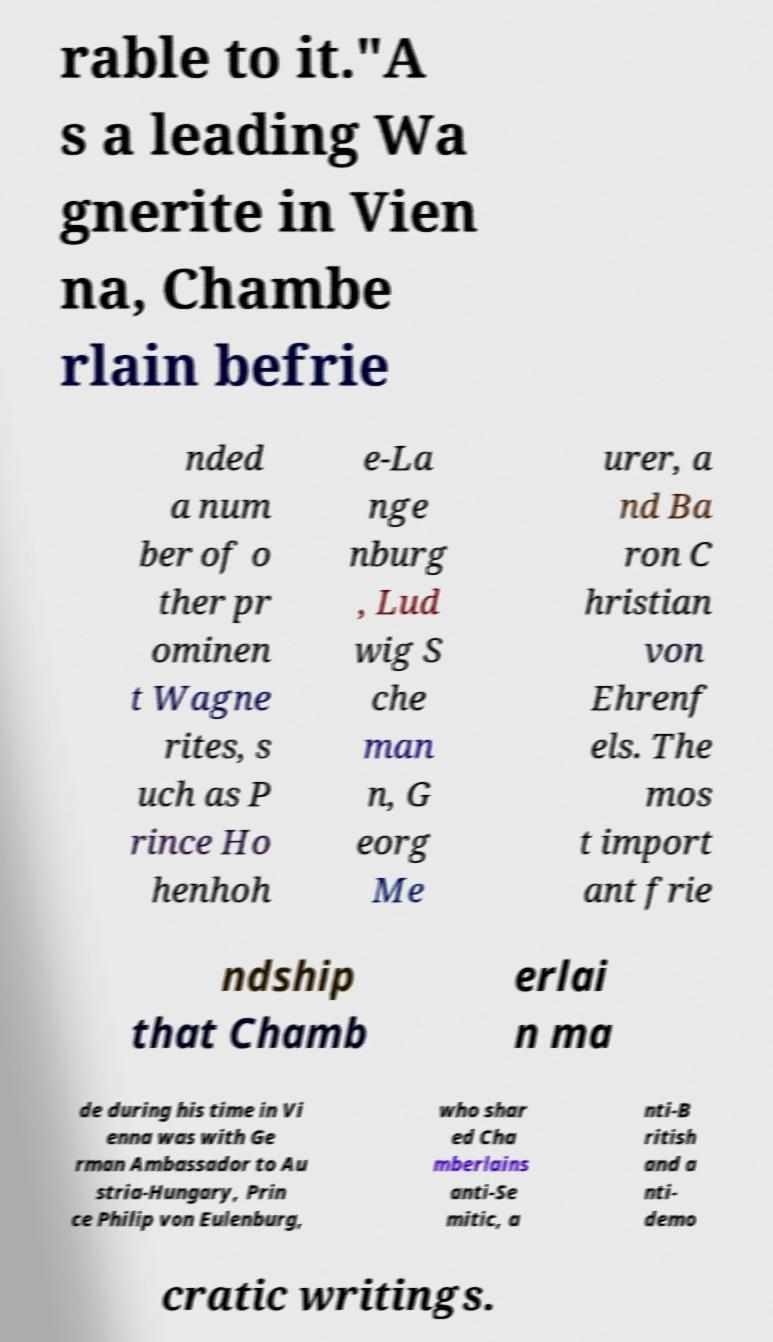For documentation purposes, I need the text within this image transcribed. Could you provide that? rable to it."A s a leading Wa gnerite in Vien na, Chambe rlain befrie nded a num ber of o ther pr ominen t Wagne rites, s uch as P rince Ho henhoh e-La nge nburg , Lud wig S che man n, G eorg Me urer, a nd Ba ron C hristian von Ehrenf els. The mos t import ant frie ndship that Chamb erlai n ma de during his time in Vi enna was with Ge rman Ambassador to Au stria-Hungary, Prin ce Philip von Eulenburg, who shar ed Cha mberlains anti-Se mitic, a nti-B ritish and a nti- demo cratic writings. 